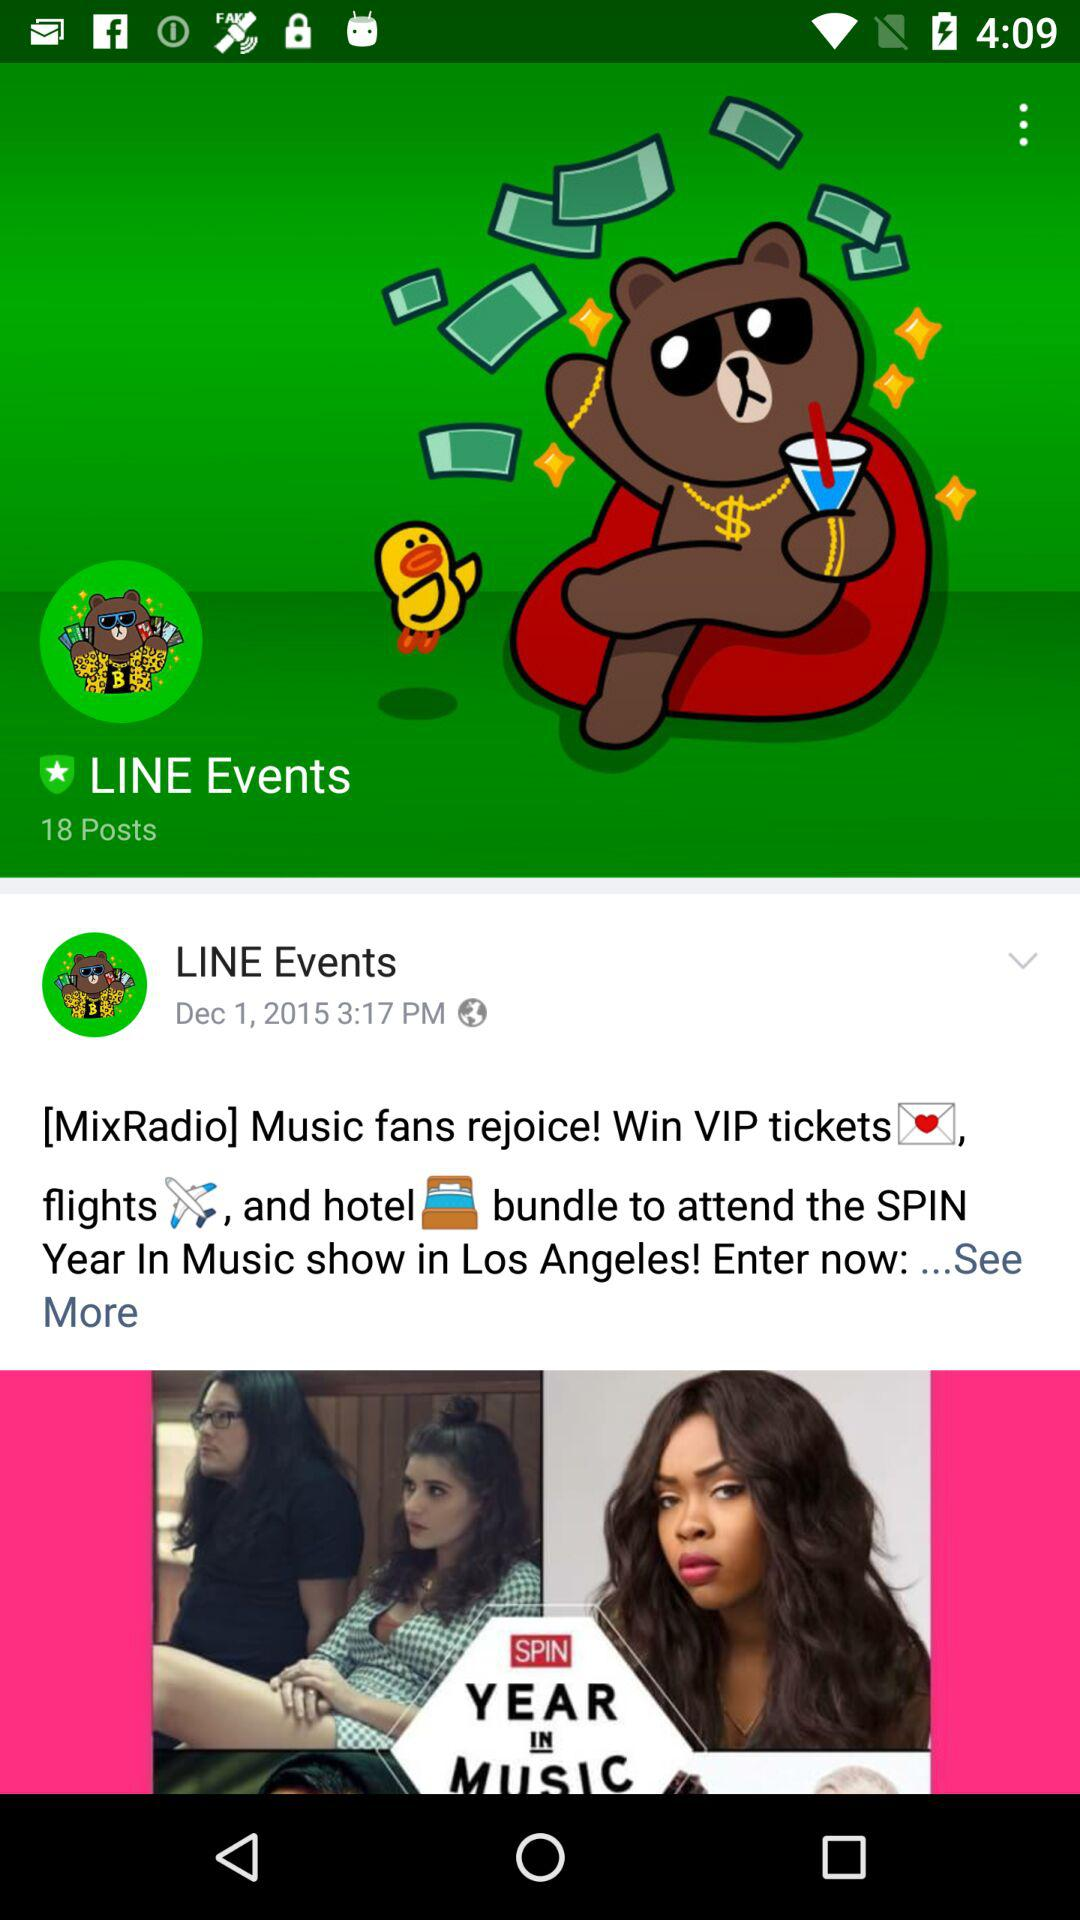How many total posts are there? The total posts are 18. 